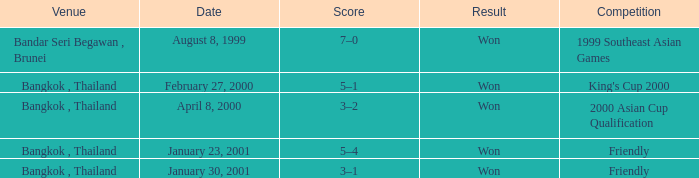During what competition was a game played with a score of 3–1? Friendly. 